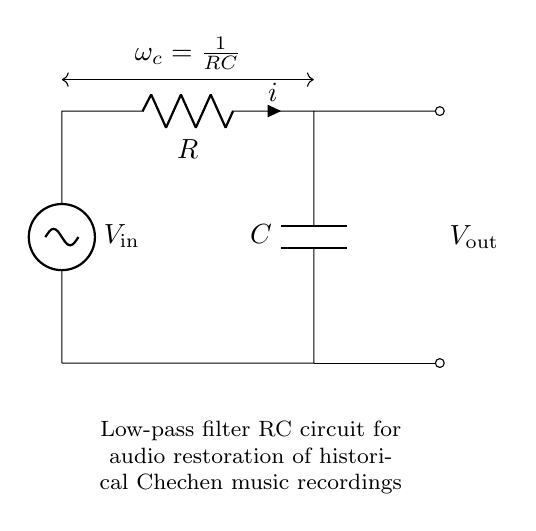What is the input voltage in this circuit? The input voltage is denoted as \( V_\text{in} \) in the circuit diagram, indicating where the signal enters the low-pass filter.
Answer: V_in What is the role of the resistor in this circuit? The resistor in this circuit is connected in series with the capacitor and acts to limit the current flowing through the circuit, affecting the filter's cut-off frequency.
Answer: Limit current What is the output voltage in this low-pass filter? The output voltage is represented as \( V_\text{out} \), which is measured across the capacitor, indicating the filtered signal.
Answer: V_out How does the cut-off frequency relate to R and C? The cut-off frequency \( \omega_c \) is given by the formula \( \frac{1}{RC} \), which shows that it is inversely proportional to the product of resistance and capacitance.
Answer: 1/RC What happens to high-frequency signals in this circuit? High-frequency signals are attenuated or reduced significantly, as the circuit is designed to allow low-frequency signals to pass while filtering out the higher frequencies.
Answer: Attenuated What is the function of the capacitor in this circuit? The capacitor stores and releases energy, smoothing out fluctuations and helping to define the time constant along with the resistor in the filtering process.
Answer: Smooth fluctuations 